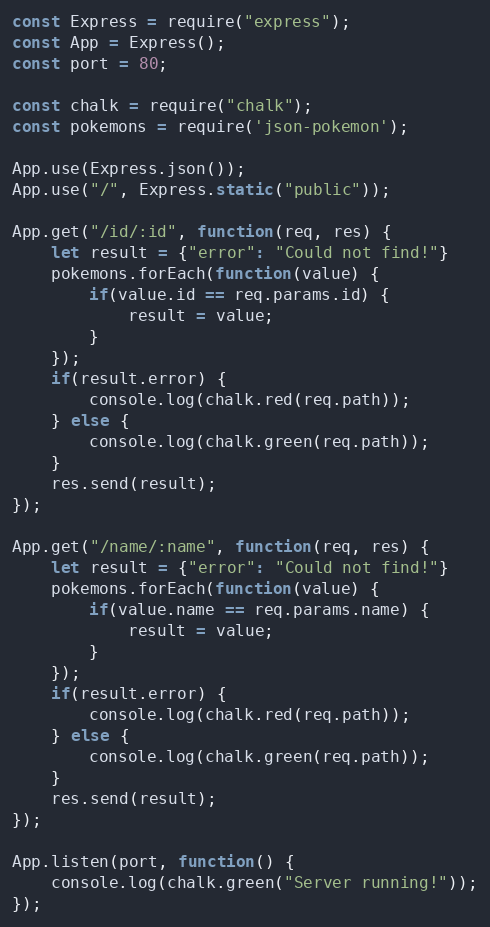<code> <loc_0><loc_0><loc_500><loc_500><_JavaScript_>const Express = require("express");
const App = Express();
const port = 80;

const chalk = require("chalk");
const pokemons = require('json-pokemon');

App.use(Express.json());
App.use("/", Express.static("public"));

App.get("/id/:id", function(req, res) {
    let result = {"error": "Could not find!"}
    pokemons.forEach(function(value) {
        if(value.id == req.params.id) {
            result = value;
        }
    });
    if(result.error) {
        console.log(chalk.red(req.path));
    } else {
        console.log(chalk.green(req.path));
    }
    res.send(result);
});

App.get("/name/:name", function(req, res) {
    let result = {"error": "Could not find!"}
    pokemons.forEach(function(value) {
        if(value.name == req.params.name) {
            result = value;
        }
    });
    if(result.error) {
        console.log(chalk.red(req.path));
    } else {
        console.log(chalk.green(req.path));
    }
    res.send(result);
});

App.listen(port, function() {
    console.log(chalk.green("Server running!"));
});</code> 